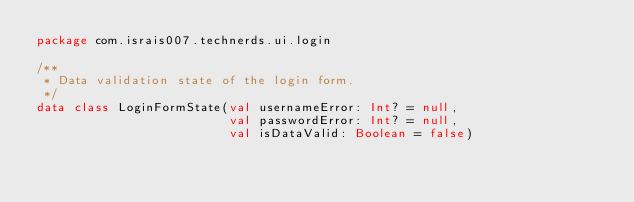Convert code to text. <code><loc_0><loc_0><loc_500><loc_500><_Kotlin_>package com.israis007.technerds.ui.login

/**
 * Data validation state of the login form.
 */
data class LoginFormState(val usernameError: Int? = null,
                          val passwordError: Int? = null,
                          val isDataValid: Boolean = false)</code> 